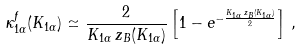Convert formula to latex. <formula><loc_0><loc_0><loc_500><loc_500>\kappa ^ { f } _ { 1 \alpha } ( K _ { 1 \alpha } ) \simeq \frac { 2 } { K _ { 1 \alpha } \, z _ { B } ( K _ { 1 \alpha } ) } \left [ 1 - e ^ { - \frac { K _ { 1 \alpha } \, z _ { B } ( K _ { 1 \alpha } ) } { 2 } } \right ] \, ,</formula> 